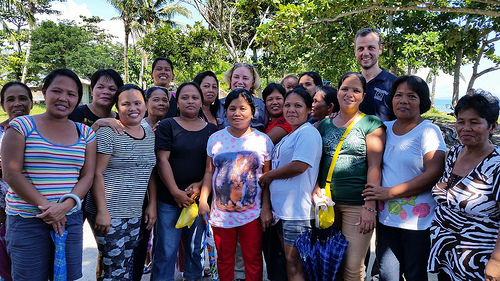<image>
Is there a dog next to the car? No. The dog is not positioned next to the car. They are located in different areas of the scene. Is there a tree above the women? No. The tree is not positioned above the women. The vertical arrangement shows a different relationship. 